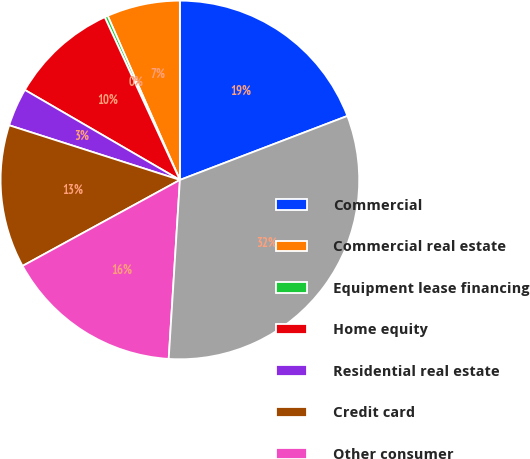Convert chart to OTSL. <chart><loc_0><loc_0><loc_500><loc_500><pie_chart><fcel>Commercial<fcel>Commercial real estate<fcel>Equipment lease financing<fcel>Home equity<fcel>Residential real estate<fcel>Credit card<fcel>Other consumer<fcel>Total<nl><fcel>19.19%<fcel>6.59%<fcel>0.29%<fcel>9.74%<fcel>3.44%<fcel>12.89%<fcel>16.04%<fcel>31.8%<nl></chart> 